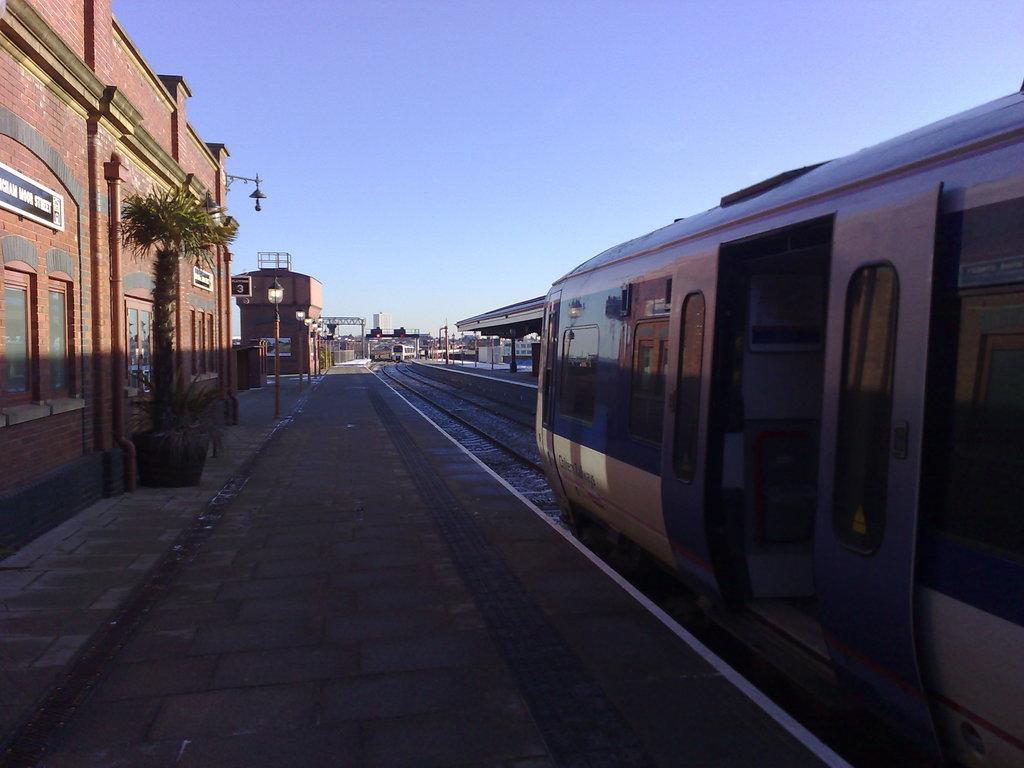Could you give a brief overview of what you see in this image? This picture is clicked in the railway station. On the right side, we see the metro train is moving on the tracks. Beside that, we see the platform. At the bottom, we see the pavement. On the left side, we see the flower pot, street lights, poles and buildings. There are buildings in the background. At the top, we see the sky. 